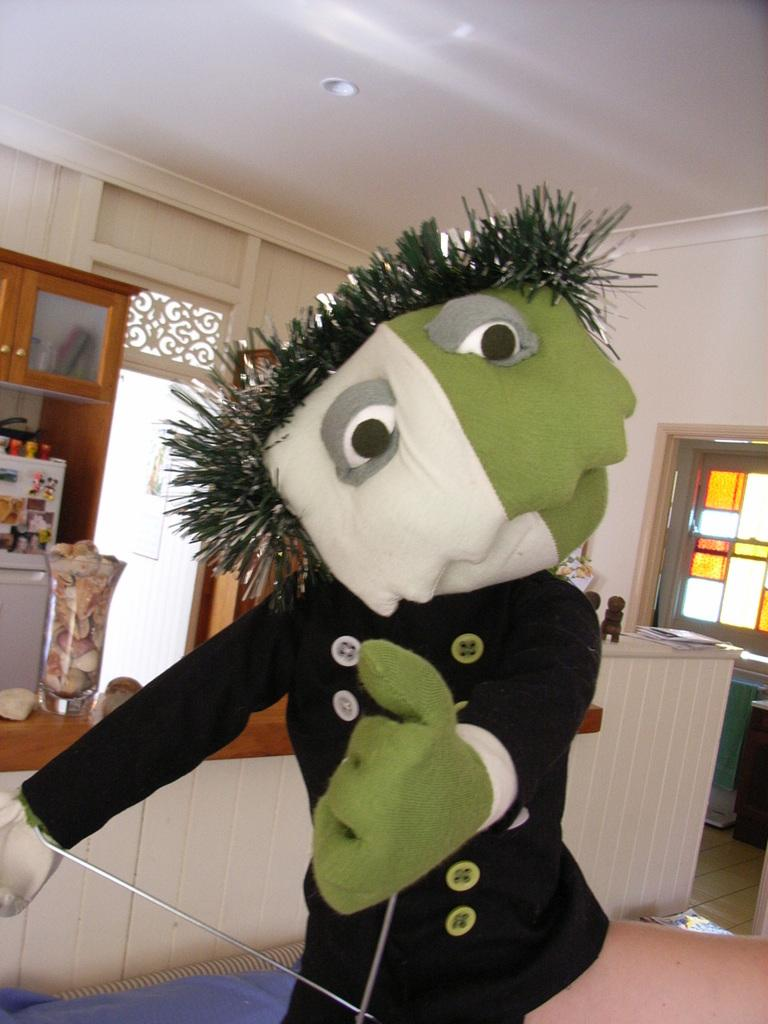What type of object can be seen in the image? There is a toy in the image. What else is present in the image besides the toy? There is a jar, cupboards, and other objects in the image. What can be seen in the background of the image? There is a wall in the background of the image. What type of apple is being used as a paperweight in the image? There is no apple present in the image, and therefore no apple is being used as a paperweight. 